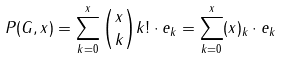Convert formula to latex. <formula><loc_0><loc_0><loc_500><loc_500>P ( G , x ) = \sum _ { k = 0 } ^ { x } { \binom { x } { k } } k ! \cdot e _ { k } = \sum _ { k = 0 } ^ { x } ( x ) _ { k } \cdot e _ { k }</formula> 